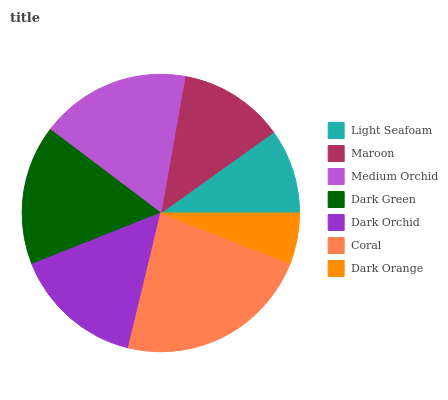Is Dark Orange the minimum?
Answer yes or no. Yes. Is Coral the maximum?
Answer yes or no. Yes. Is Maroon the minimum?
Answer yes or no. No. Is Maroon the maximum?
Answer yes or no. No. Is Maroon greater than Light Seafoam?
Answer yes or no. Yes. Is Light Seafoam less than Maroon?
Answer yes or no. Yes. Is Light Seafoam greater than Maroon?
Answer yes or no. No. Is Maroon less than Light Seafoam?
Answer yes or no. No. Is Dark Orchid the high median?
Answer yes or no. Yes. Is Dark Orchid the low median?
Answer yes or no. Yes. Is Dark Orange the high median?
Answer yes or no. No. Is Coral the low median?
Answer yes or no. No. 